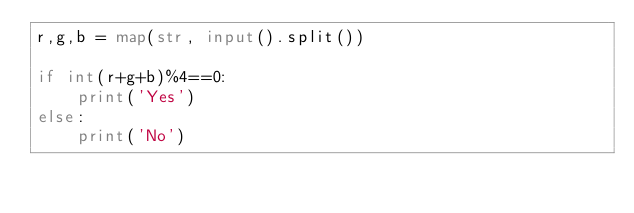<code> <loc_0><loc_0><loc_500><loc_500><_Python_>r,g,b = map(str, input().split())

if int(r+g+b)%4==0:
    print('Yes')
else:
    print('No')</code> 